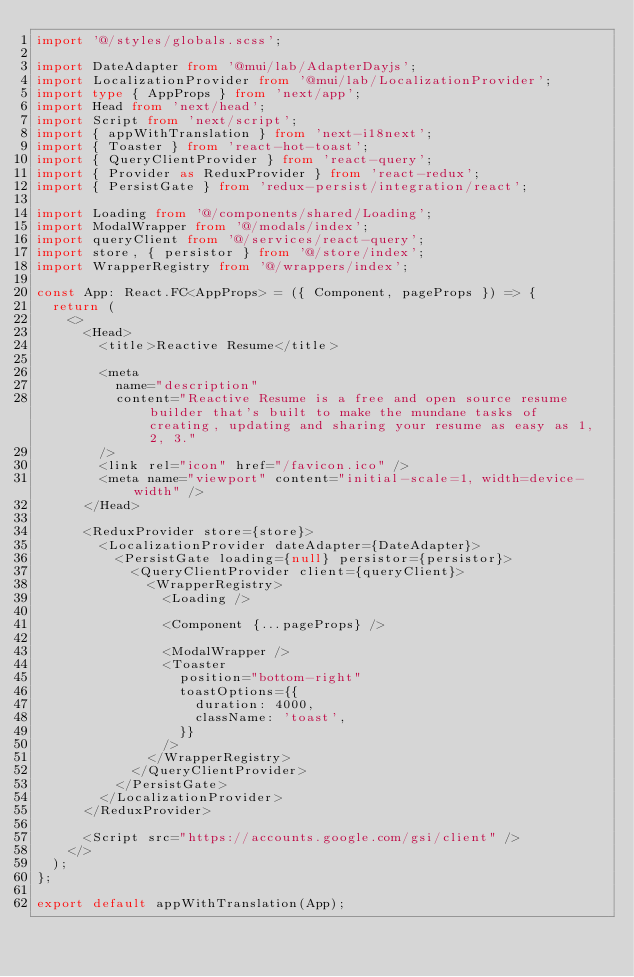Convert code to text. <code><loc_0><loc_0><loc_500><loc_500><_TypeScript_>import '@/styles/globals.scss';

import DateAdapter from '@mui/lab/AdapterDayjs';
import LocalizationProvider from '@mui/lab/LocalizationProvider';
import type { AppProps } from 'next/app';
import Head from 'next/head';
import Script from 'next/script';
import { appWithTranslation } from 'next-i18next';
import { Toaster } from 'react-hot-toast';
import { QueryClientProvider } from 'react-query';
import { Provider as ReduxProvider } from 'react-redux';
import { PersistGate } from 'redux-persist/integration/react';

import Loading from '@/components/shared/Loading';
import ModalWrapper from '@/modals/index';
import queryClient from '@/services/react-query';
import store, { persistor } from '@/store/index';
import WrapperRegistry from '@/wrappers/index';

const App: React.FC<AppProps> = ({ Component, pageProps }) => {
  return (
    <>
      <Head>
        <title>Reactive Resume</title>

        <meta
          name="description"
          content="Reactive Resume is a free and open source resume builder that's built to make the mundane tasks of creating, updating and sharing your resume as easy as 1, 2, 3."
        />
        <link rel="icon" href="/favicon.ico" />
        <meta name="viewport" content="initial-scale=1, width=device-width" />
      </Head>

      <ReduxProvider store={store}>
        <LocalizationProvider dateAdapter={DateAdapter}>
          <PersistGate loading={null} persistor={persistor}>
            <QueryClientProvider client={queryClient}>
              <WrapperRegistry>
                <Loading />

                <Component {...pageProps} />

                <ModalWrapper />
                <Toaster
                  position="bottom-right"
                  toastOptions={{
                    duration: 4000,
                    className: 'toast',
                  }}
                />
              </WrapperRegistry>
            </QueryClientProvider>
          </PersistGate>
        </LocalizationProvider>
      </ReduxProvider>

      <Script src="https://accounts.google.com/gsi/client" />
    </>
  );
};

export default appWithTranslation(App);
</code> 